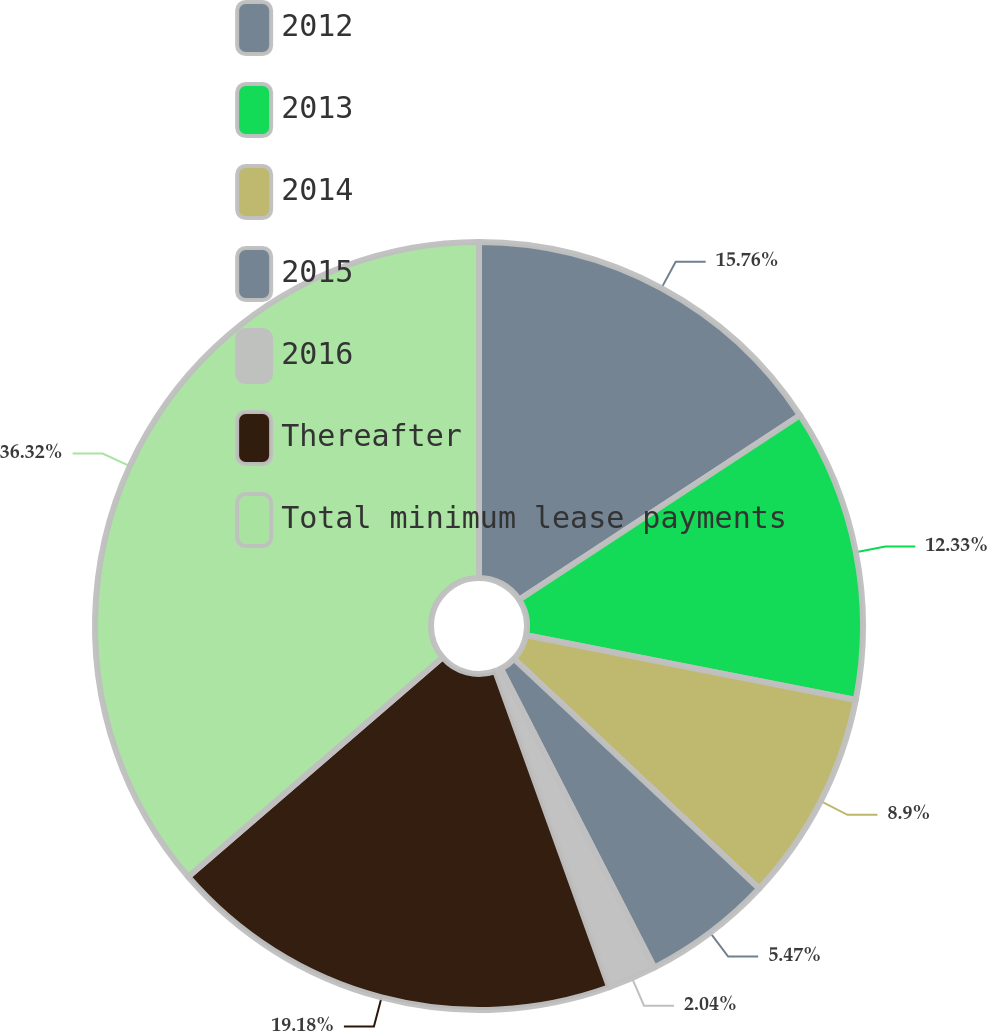Convert chart to OTSL. <chart><loc_0><loc_0><loc_500><loc_500><pie_chart><fcel>2012<fcel>2013<fcel>2014<fcel>2015<fcel>2016<fcel>Thereafter<fcel>Total minimum lease payments<nl><fcel>15.76%<fcel>12.33%<fcel>8.9%<fcel>5.47%<fcel>2.04%<fcel>19.18%<fcel>36.33%<nl></chart> 